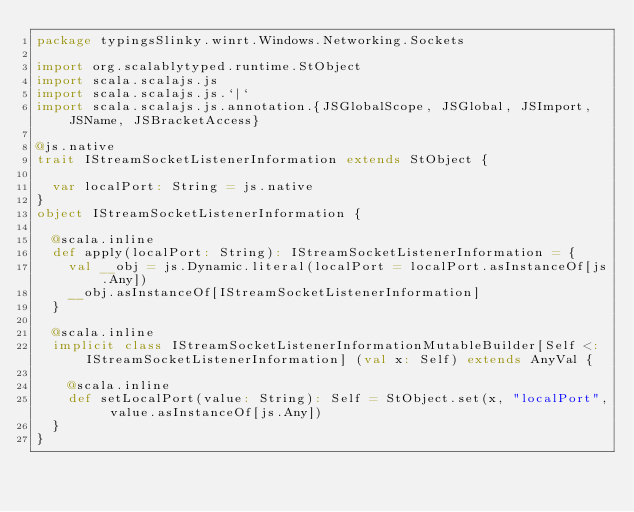<code> <loc_0><loc_0><loc_500><loc_500><_Scala_>package typingsSlinky.winrt.Windows.Networking.Sockets

import org.scalablytyped.runtime.StObject
import scala.scalajs.js
import scala.scalajs.js.`|`
import scala.scalajs.js.annotation.{JSGlobalScope, JSGlobal, JSImport, JSName, JSBracketAccess}

@js.native
trait IStreamSocketListenerInformation extends StObject {
  
  var localPort: String = js.native
}
object IStreamSocketListenerInformation {
  
  @scala.inline
  def apply(localPort: String): IStreamSocketListenerInformation = {
    val __obj = js.Dynamic.literal(localPort = localPort.asInstanceOf[js.Any])
    __obj.asInstanceOf[IStreamSocketListenerInformation]
  }
  
  @scala.inline
  implicit class IStreamSocketListenerInformationMutableBuilder[Self <: IStreamSocketListenerInformation] (val x: Self) extends AnyVal {
    
    @scala.inline
    def setLocalPort(value: String): Self = StObject.set(x, "localPort", value.asInstanceOf[js.Any])
  }
}
</code> 